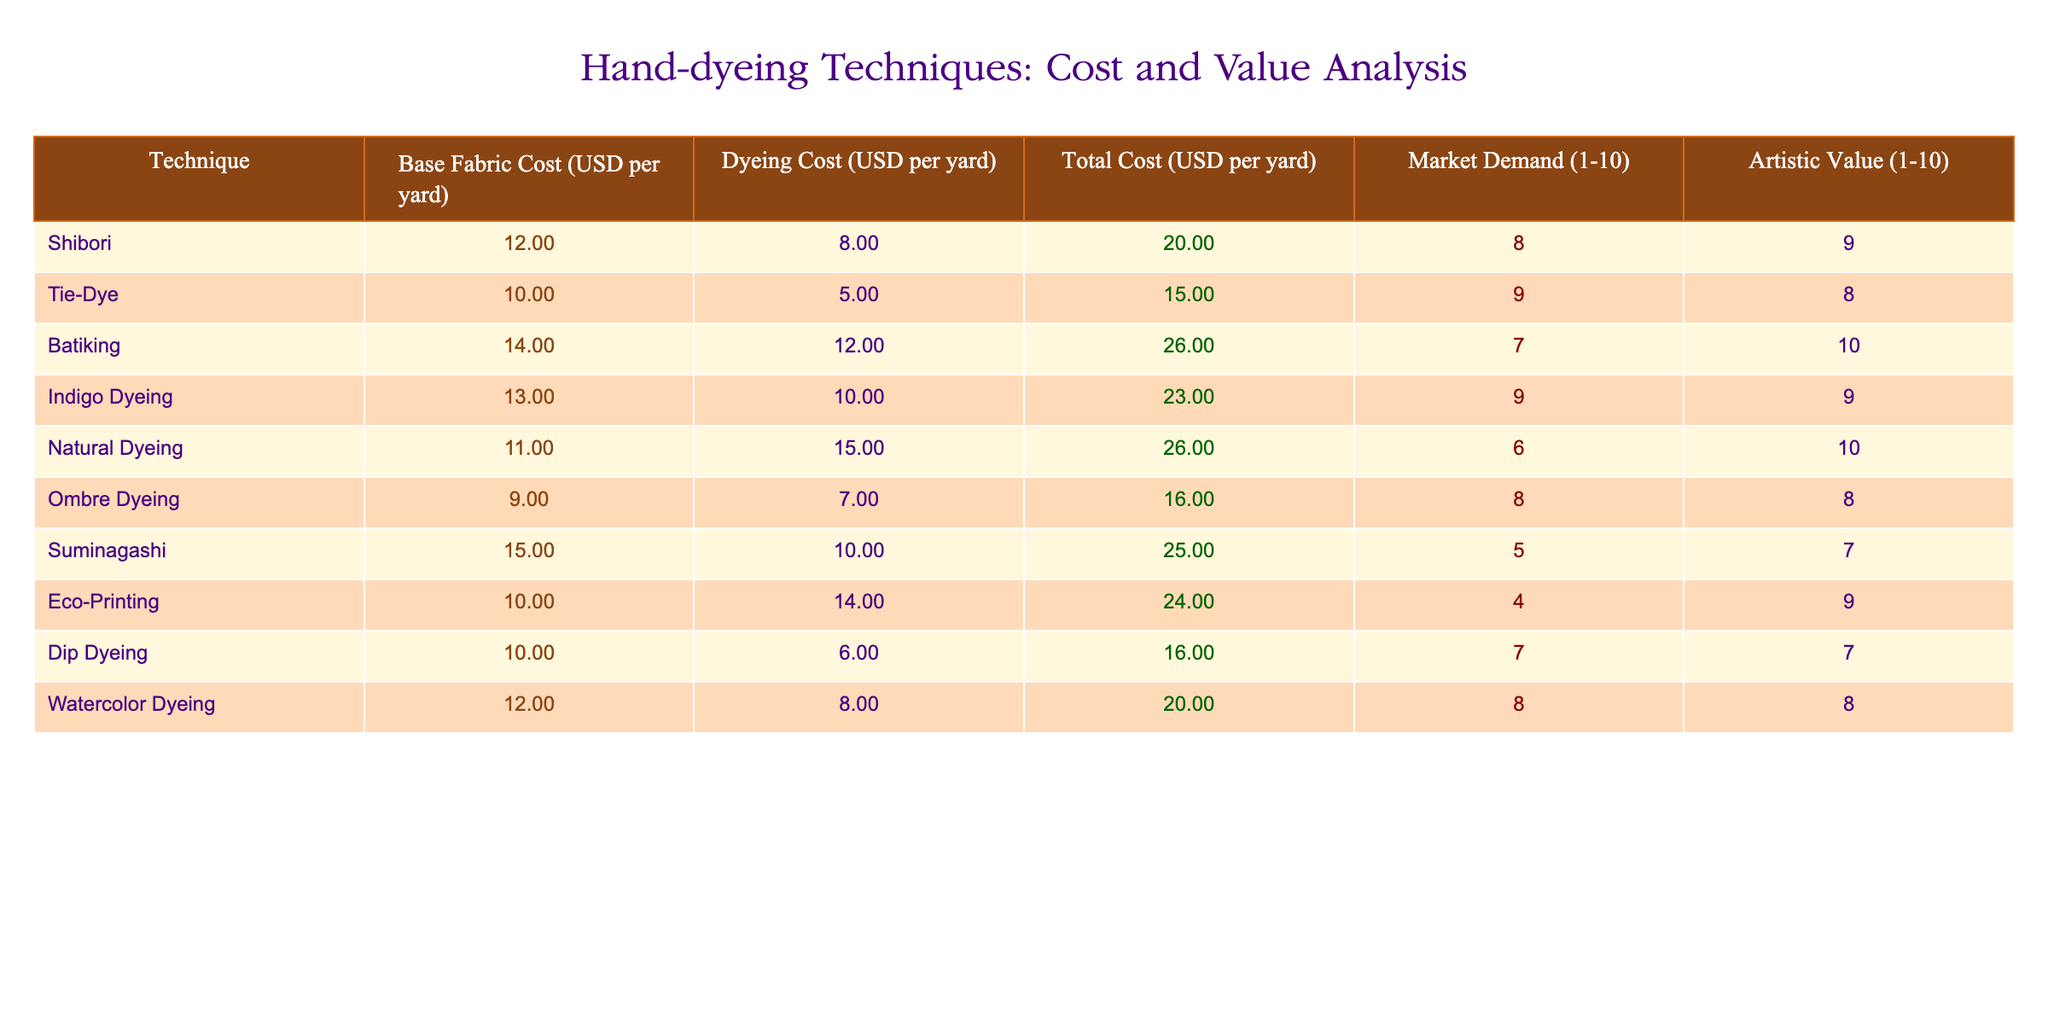What is the total cost per yard for Tie-Dye? The table shows that the total cost for Tie-Dye is listed as 15.00 USD per yard.
Answer: 15.00 USD Which dyeing technique has the highest artistic value? Looking at the "Artistic Value" column, Batiking has the highest score of 10.
Answer: Batiking What is the average base fabric cost across all techniques? The base fabric costs are: 12.00, 10.00, 14.00, 13.00, 11.00, 9.00, 15.00, 10.00, 10.00, 12.00. Summing them gives 126.00 USD, and dividing by 10 (number of techniques) results in an average of 12.60 USD.
Answer: 12.60 USD Is the dyeing cost for Natural Dyeing greater than the average dyeing cost for all techniques? The dyeing costs are: 8.00, 5.00, 12.00, 10.00, 15.00, 7.00, 10.00, 14.00, 6.00, 8.00. Summing them gives  8.00+5.00+12.00+10.00+15.00+7.00+10.00+14.00+6.00+8.00 =  85.00 USD, averaging this gives 8.50 USD. Since 15.00 is greater than 8.50, the answer is true.
Answer: Yes What is the difference in total cost between Ombre Dyeing and Indigo Dyeing? The total cost for Ombre Dyeing is 16.00 USD, and for Indigo Dyeing it is 23.00 USD. The difference is calculated as 23.00 - 16.00 = 7.00 USD.
Answer: 7.00 USD How many techniques have a market demand rating of 8 or higher? We look at the "Market Demand" column, which shows the following ratings: 8, 9, 9, 8, 5, 4, 7, 7, 8. There are five techniques (Tie-Dye, Indigo Dyeing, Ombre Dyeing, Shibori, and Watercolor Dyeing) with a rating of 8 or higher.
Answer: 5 techniques 